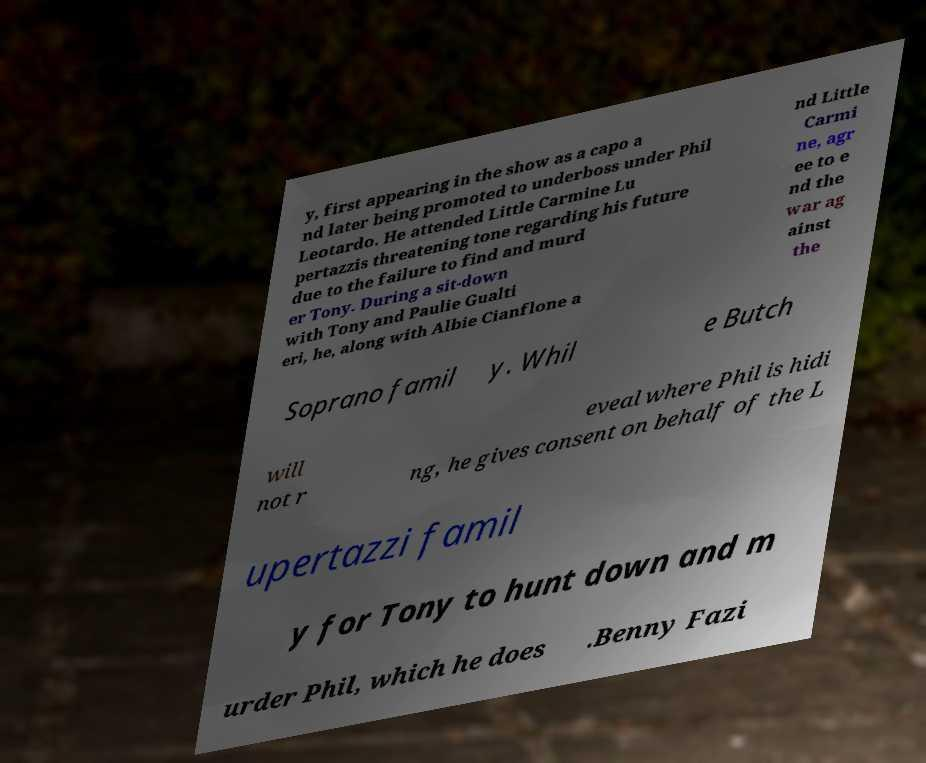Could you assist in decoding the text presented in this image and type it out clearly? y, first appearing in the show as a capo a nd later being promoted to underboss under Phil Leotardo. He attended Little Carmine Lu pertazzis threatening tone regarding his future due to the failure to find and murd er Tony. During a sit-down with Tony and Paulie Gualti eri, he, along with Albie Cianflone a nd Little Carmi ne, agr ee to e nd the war ag ainst the Soprano famil y. Whil e Butch will not r eveal where Phil is hidi ng, he gives consent on behalf of the L upertazzi famil y for Tony to hunt down and m urder Phil, which he does .Benny Fazi 